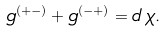Convert formula to latex. <formula><loc_0><loc_0><loc_500><loc_500>g ^ { ( + - ) } + g ^ { ( - + ) } = d \, \chi .</formula> 